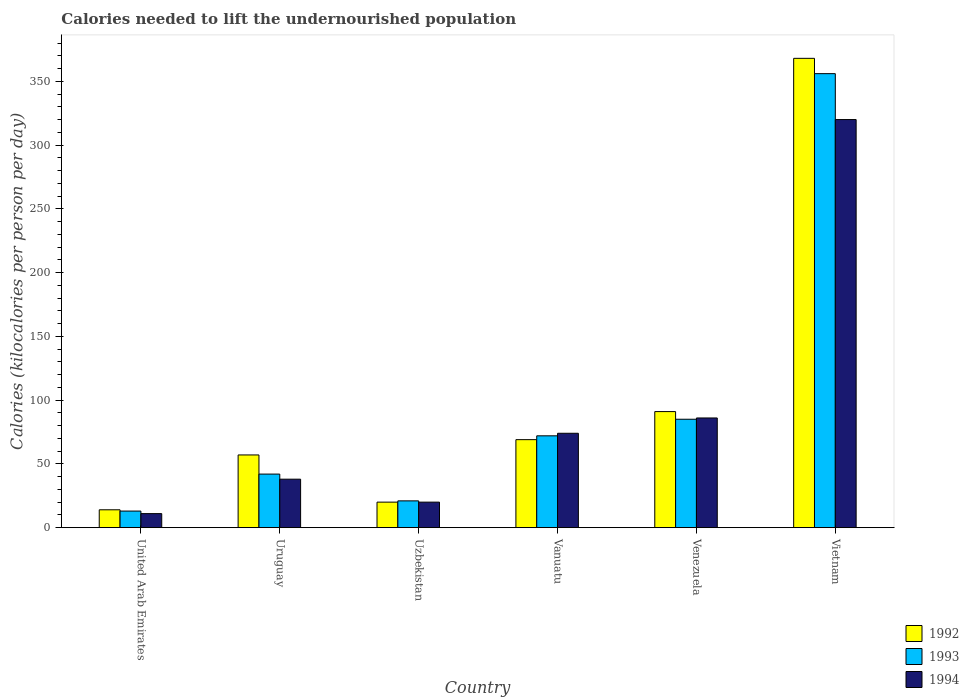How many different coloured bars are there?
Offer a very short reply. 3. What is the label of the 4th group of bars from the left?
Offer a very short reply. Vanuatu. In how many cases, is the number of bars for a given country not equal to the number of legend labels?
Offer a very short reply. 0. Across all countries, what is the maximum total calories needed to lift the undernourished population in 1993?
Offer a very short reply. 356. In which country was the total calories needed to lift the undernourished population in 1994 maximum?
Ensure brevity in your answer.  Vietnam. In which country was the total calories needed to lift the undernourished population in 1992 minimum?
Keep it short and to the point. United Arab Emirates. What is the total total calories needed to lift the undernourished population in 1993 in the graph?
Ensure brevity in your answer.  589. What is the difference between the total calories needed to lift the undernourished population in 1992 in Uruguay and that in Vietnam?
Your answer should be very brief. -311. What is the difference between the total calories needed to lift the undernourished population in 1992 in United Arab Emirates and the total calories needed to lift the undernourished population in 1993 in Vanuatu?
Ensure brevity in your answer.  -58. What is the average total calories needed to lift the undernourished population in 1994 per country?
Make the answer very short. 91.5. What is the difference between the total calories needed to lift the undernourished population of/in 1994 and total calories needed to lift the undernourished population of/in 1993 in Vietnam?
Give a very brief answer. -36. In how many countries, is the total calories needed to lift the undernourished population in 1994 greater than 190 kilocalories?
Your response must be concise. 1. What is the ratio of the total calories needed to lift the undernourished population in 1993 in Uruguay to that in Venezuela?
Offer a terse response. 0.49. Is the total calories needed to lift the undernourished population in 1992 in Uzbekistan less than that in Venezuela?
Ensure brevity in your answer.  Yes. What is the difference between the highest and the second highest total calories needed to lift the undernourished population in 1992?
Ensure brevity in your answer.  277. What is the difference between the highest and the lowest total calories needed to lift the undernourished population in 1993?
Your response must be concise. 343. In how many countries, is the total calories needed to lift the undernourished population in 1994 greater than the average total calories needed to lift the undernourished population in 1994 taken over all countries?
Ensure brevity in your answer.  1. Is the sum of the total calories needed to lift the undernourished population in 1994 in Venezuela and Vietnam greater than the maximum total calories needed to lift the undernourished population in 1993 across all countries?
Your answer should be very brief. Yes. What does the 2nd bar from the left in Vietnam represents?
Offer a terse response. 1993. What does the 3rd bar from the right in Uruguay represents?
Ensure brevity in your answer.  1992. Is it the case that in every country, the sum of the total calories needed to lift the undernourished population in 1993 and total calories needed to lift the undernourished population in 1992 is greater than the total calories needed to lift the undernourished population in 1994?
Your response must be concise. Yes. How many countries are there in the graph?
Keep it short and to the point. 6. What is the difference between two consecutive major ticks on the Y-axis?
Keep it short and to the point. 50. Does the graph contain any zero values?
Offer a very short reply. No. How are the legend labels stacked?
Provide a short and direct response. Vertical. What is the title of the graph?
Your answer should be compact. Calories needed to lift the undernourished population. What is the label or title of the Y-axis?
Your response must be concise. Calories (kilocalories per person per day). What is the Calories (kilocalories per person per day) in 1992 in United Arab Emirates?
Your response must be concise. 14. What is the Calories (kilocalories per person per day) in 1993 in United Arab Emirates?
Offer a terse response. 13. What is the Calories (kilocalories per person per day) in 1994 in United Arab Emirates?
Give a very brief answer. 11. What is the Calories (kilocalories per person per day) in 1993 in Uruguay?
Give a very brief answer. 42. What is the Calories (kilocalories per person per day) of 1994 in Uruguay?
Provide a short and direct response. 38. What is the Calories (kilocalories per person per day) of 1992 in Vanuatu?
Provide a succinct answer. 69. What is the Calories (kilocalories per person per day) in 1994 in Vanuatu?
Offer a terse response. 74. What is the Calories (kilocalories per person per day) in 1992 in Venezuela?
Offer a very short reply. 91. What is the Calories (kilocalories per person per day) in 1992 in Vietnam?
Your answer should be very brief. 368. What is the Calories (kilocalories per person per day) in 1993 in Vietnam?
Your answer should be compact. 356. What is the Calories (kilocalories per person per day) of 1994 in Vietnam?
Provide a succinct answer. 320. Across all countries, what is the maximum Calories (kilocalories per person per day) of 1992?
Ensure brevity in your answer.  368. Across all countries, what is the maximum Calories (kilocalories per person per day) of 1993?
Your answer should be compact. 356. Across all countries, what is the maximum Calories (kilocalories per person per day) in 1994?
Offer a very short reply. 320. What is the total Calories (kilocalories per person per day) in 1992 in the graph?
Provide a succinct answer. 619. What is the total Calories (kilocalories per person per day) in 1993 in the graph?
Provide a short and direct response. 589. What is the total Calories (kilocalories per person per day) of 1994 in the graph?
Make the answer very short. 549. What is the difference between the Calories (kilocalories per person per day) of 1992 in United Arab Emirates and that in Uruguay?
Provide a succinct answer. -43. What is the difference between the Calories (kilocalories per person per day) of 1993 in United Arab Emirates and that in Uruguay?
Provide a short and direct response. -29. What is the difference between the Calories (kilocalories per person per day) of 1994 in United Arab Emirates and that in Uruguay?
Make the answer very short. -27. What is the difference between the Calories (kilocalories per person per day) of 1992 in United Arab Emirates and that in Uzbekistan?
Provide a short and direct response. -6. What is the difference between the Calories (kilocalories per person per day) in 1994 in United Arab Emirates and that in Uzbekistan?
Provide a short and direct response. -9. What is the difference between the Calories (kilocalories per person per day) of 1992 in United Arab Emirates and that in Vanuatu?
Your answer should be compact. -55. What is the difference between the Calories (kilocalories per person per day) of 1993 in United Arab Emirates and that in Vanuatu?
Offer a very short reply. -59. What is the difference between the Calories (kilocalories per person per day) of 1994 in United Arab Emirates and that in Vanuatu?
Give a very brief answer. -63. What is the difference between the Calories (kilocalories per person per day) of 1992 in United Arab Emirates and that in Venezuela?
Provide a succinct answer. -77. What is the difference between the Calories (kilocalories per person per day) of 1993 in United Arab Emirates and that in Venezuela?
Provide a succinct answer. -72. What is the difference between the Calories (kilocalories per person per day) in 1994 in United Arab Emirates and that in Venezuela?
Your answer should be compact. -75. What is the difference between the Calories (kilocalories per person per day) of 1992 in United Arab Emirates and that in Vietnam?
Your answer should be compact. -354. What is the difference between the Calories (kilocalories per person per day) of 1993 in United Arab Emirates and that in Vietnam?
Your answer should be very brief. -343. What is the difference between the Calories (kilocalories per person per day) of 1994 in United Arab Emirates and that in Vietnam?
Provide a short and direct response. -309. What is the difference between the Calories (kilocalories per person per day) of 1994 in Uruguay and that in Uzbekistan?
Provide a succinct answer. 18. What is the difference between the Calories (kilocalories per person per day) of 1992 in Uruguay and that in Vanuatu?
Your answer should be very brief. -12. What is the difference between the Calories (kilocalories per person per day) of 1994 in Uruguay and that in Vanuatu?
Offer a terse response. -36. What is the difference between the Calories (kilocalories per person per day) of 1992 in Uruguay and that in Venezuela?
Provide a short and direct response. -34. What is the difference between the Calories (kilocalories per person per day) in 1993 in Uruguay and that in Venezuela?
Provide a short and direct response. -43. What is the difference between the Calories (kilocalories per person per day) in 1994 in Uruguay and that in Venezuela?
Your answer should be very brief. -48. What is the difference between the Calories (kilocalories per person per day) of 1992 in Uruguay and that in Vietnam?
Make the answer very short. -311. What is the difference between the Calories (kilocalories per person per day) in 1993 in Uruguay and that in Vietnam?
Provide a short and direct response. -314. What is the difference between the Calories (kilocalories per person per day) in 1994 in Uruguay and that in Vietnam?
Your response must be concise. -282. What is the difference between the Calories (kilocalories per person per day) in 1992 in Uzbekistan and that in Vanuatu?
Give a very brief answer. -49. What is the difference between the Calories (kilocalories per person per day) of 1993 in Uzbekistan and that in Vanuatu?
Ensure brevity in your answer.  -51. What is the difference between the Calories (kilocalories per person per day) of 1994 in Uzbekistan and that in Vanuatu?
Offer a terse response. -54. What is the difference between the Calories (kilocalories per person per day) in 1992 in Uzbekistan and that in Venezuela?
Keep it short and to the point. -71. What is the difference between the Calories (kilocalories per person per day) of 1993 in Uzbekistan and that in Venezuela?
Provide a succinct answer. -64. What is the difference between the Calories (kilocalories per person per day) of 1994 in Uzbekistan and that in Venezuela?
Ensure brevity in your answer.  -66. What is the difference between the Calories (kilocalories per person per day) in 1992 in Uzbekistan and that in Vietnam?
Your answer should be very brief. -348. What is the difference between the Calories (kilocalories per person per day) in 1993 in Uzbekistan and that in Vietnam?
Provide a short and direct response. -335. What is the difference between the Calories (kilocalories per person per day) of 1994 in Uzbekistan and that in Vietnam?
Your answer should be compact. -300. What is the difference between the Calories (kilocalories per person per day) in 1993 in Vanuatu and that in Venezuela?
Provide a succinct answer. -13. What is the difference between the Calories (kilocalories per person per day) in 1992 in Vanuatu and that in Vietnam?
Provide a short and direct response. -299. What is the difference between the Calories (kilocalories per person per day) in 1993 in Vanuatu and that in Vietnam?
Your response must be concise. -284. What is the difference between the Calories (kilocalories per person per day) of 1994 in Vanuatu and that in Vietnam?
Offer a terse response. -246. What is the difference between the Calories (kilocalories per person per day) of 1992 in Venezuela and that in Vietnam?
Ensure brevity in your answer.  -277. What is the difference between the Calories (kilocalories per person per day) of 1993 in Venezuela and that in Vietnam?
Your answer should be very brief. -271. What is the difference between the Calories (kilocalories per person per day) in 1994 in Venezuela and that in Vietnam?
Keep it short and to the point. -234. What is the difference between the Calories (kilocalories per person per day) of 1993 in United Arab Emirates and the Calories (kilocalories per person per day) of 1994 in Uruguay?
Keep it short and to the point. -25. What is the difference between the Calories (kilocalories per person per day) of 1992 in United Arab Emirates and the Calories (kilocalories per person per day) of 1993 in Uzbekistan?
Your answer should be compact. -7. What is the difference between the Calories (kilocalories per person per day) of 1992 in United Arab Emirates and the Calories (kilocalories per person per day) of 1993 in Vanuatu?
Your response must be concise. -58. What is the difference between the Calories (kilocalories per person per day) in 1992 in United Arab Emirates and the Calories (kilocalories per person per day) in 1994 in Vanuatu?
Your answer should be compact. -60. What is the difference between the Calories (kilocalories per person per day) of 1993 in United Arab Emirates and the Calories (kilocalories per person per day) of 1994 in Vanuatu?
Provide a succinct answer. -61. What is the difference between the Calories (kilocalories per person per day) of 1992 in United Arab Emirates and the Calories (kilocalories per person per day) of 1993 in Venezuela?
Make the answer very short. -71. What is the difference between the Calories (kilocalories per person per day) of 1992 in United Arab Emirates and the Calories (kilocalories per person per day) of 1994 in Venezuela?
Give a very brief answer. -72. What is the difference between the Calories (kilocalories per person per day) in 1993 in United Arab Emirates and the Calories (kilocalories per person per day) in 1994 in Venezuela?
Provide a short and direct response. -73. What is the difference between the Calories (kilocalories per person per day) of 1992 in United Arab Emirates and the Calories (kilocalories per person per day) of 1993 in Vietnam?
Your response must be concise. -342. What is the difference between the Calories (kilocalories per person per day) in 1992 in United Arab Emirates and the Calories (kilocalories per person per day) in 1994 in Vietnam?
Your answer should be very brief. -306. What is the difference between the Calories (kilocalories per person per day) in 1993 in United Arab Emirates and the Calories (kilocalories per person per day) in 1994 in Vietnam?
Give a very brief answer. -307. What is the difference between the Calories (kilocalories per person per day) of 1992 in Uruguay and the Calories (kilocalories per person per day) of 1993 in Uzbekistan?
Your answer should be compact. 36. What is the difference between the Calories (kilocalories per person per day) in 1992 in Uruguay and the Calories (kilocalories per person per day) in 1994 in Uzbekistan?
Offer a terse response. 37. What is the difference between the Calories (kilocalories per person per day) of 1993 in Uruguay and the Calories (kilocalories per person per day) of 1994 in Uzbekistan?
Offer a very short reply. 22. What is the difference between the Calories (kilocalories per person per day) of 1992 in Uruguay and the Calories (kilocalories per person per day) of 1994 in Vanuatu?
Provide a succinct answer. -17. What is the difference between the Calories (kilocalories per person per day) of 1993 in Uruguay and the Calories (kilocalories per person per day) of 1994 in Vanuatu?
Offer a terse response. -32. What is the difference between the Calories (kilocalories per person per day) of 1992 in Uruguay and the Calories (kilocalories per person per day) of 1993 in Venezuela?
Your answer should be very brief. -28. What is the difference between the Calories (kilocalories per person per day) in 1992 in Uruguay and the Calories (kilocalories per person per day) in 1994 in Venezuela?
Give a very brief answer. -29. What is the difference between the Calories (kilocalories per person per day) in 1993 in Uruguay and the Calories (kilocalories per person per day) in 1994 in Venezuela?
Offer a very short reply. -44. What is the difference between the Calories (kilocalories per person per day) of 1992 in Uruguay and the Calories (kilocalories per person per day) of 1993 in Vietnam?
Make the answer very short. -299. What is the difference between the Calories (kilocalories per person per day) in 1992 in Uruguay and the Calories (kilocalories per person per day) in 1994 in Vietnam?
Give a very brief answer. -263. What is the difference between the Calories (kilocalories per person per day) in 1993 in Uruguay and the Calories (kilocalories per person per day) in 1994 in Vietnam?
Offer a very short reply. -278. What is the difference between the Calories (kilocalories per person per day) of 1992 in Uzbekistan and the Calories (kilocalories per person per day) of 1993 in Vanuatu?
Your response must be concise. -52. What is the difference between the Calories (kilocalories per person per day) in 1992 in Uzbekistan and the Calories (kilocalories per person per day) in 1994 in Vanuatu?
Keep it short and to the point. -54. What is the difference between the Calories (kilocalories per person per day) of 1993 in Uzbekistan and the Calories (kilocalories per person per day) of 1994 in Vanuatu?
Your answer should be compact. -53. What is the difference between the Calories (kilocalories per person per day) in 1992 in Uzbekistan and the Calories (kilocalories per person per day) in 1993 in Venezuela?
Keep it short and to the point. -65. What is the difference between the Calories (kilocalories per person per day) of 1992 in Uzbekistan and the Calories (kilocalories per person per day) of 1994 in Venezuela?
Your response must be concise. -66. What is the difference between the Calories (kilocalories per person per day) of 1993 in Uzbekistan and the Calories (kilocalories per person per day) of 1994 in Venezuela?
Provide a succinct answer. -65. What is the difference between the Calories (kilocalories per person per day) in 1992 in Uzbekistan and the Calories (kilocalories per person per day) in 1993 in Vietnam?
Keep it short and to the point. -336. What is the difference between the Calories (kilocalories per person per day) of 1992 in Uzbekistan and the Calories (kilocalories per person per day) of 1994 in Vietnam?
Provide a short and direct response. -300. What is the difference between the Calories (kilocalories per person per day) in 1993 in Uzbekistan and the Calories (kilocalories per person per day) in 1994 in Vietnam?
Provide a short and direct response. -299. What is the difference between the Calories (kilocalories per person per day) of 1993 in Vanuatu and the Calories (kilocalories per person per day) of 1994 in Venezuela?
Your answer should be very brief. -14. What is the difference between the Calories (kilocalories per person per day) of 1992 in Vanuatu and the Calories (kilocalories per person per day) of 1993 in Vietnam?
Your answer should be very brief. -287. What is the difference between the Calories (kilocalories per person per day) in 1992 in Vanuatu and the Calories (kilocalories per person per day) in 1994 in Vietnam?
Make the answer very short. -251. What is the difference between the Calories (kilocalories per person per day) of 1993 in Vanuatu and the Calories (kilocalories per person per day) of 1994 in Vietnam?
Ensure brevity in your answer.  -248. What is the difference between the Calories (kilocalories per person per day) in 1992 in Venezuela and the Calories (kilocalories per person per day) in 1993 in Vietnam?
Give a very brief answer. -265. What is the difference between the Calories (kilocalories per person per day) of 1992 in Venezuela and the Calories (kilocalories per person per day) of 1994 in Vietnam?
Keep it short and to the point. -229. What is the difference between the Calories (kilocalories per person per day) in 1993 in Venezuela and the Calories (kilocalories per person per day) in 1994 in Vietnam?
Your answer should be compact. -235. What is the average Calories (kilocalories per person per day) in 1992 per country?
Keep it short and to the point. 103.17. What is the average Calories (kilocalories per person per day) of 1993 per country?
Make the answer very short. 98.17. What is the average Calories (kilocalories per person per day) of 1994 per country?
Provide a short and direct response. 91.5. What is the difference between the Calories (kilocalories per person per day) of 1992 and Calories (kilocalories per person per day) of 1994 in United Arab Emirates?
Offer a very short reply. 3. What is the difference between the Calories (kilocalories per person per day) in 1993 and Calories (kilocalories per person per day) in 1994 in United Arab Emirates?
Offer a terse response. 2. What is the difference between the Calories (kilocalories per person per day) in 1992 and Calories (kilocalories per person per day) in 1993 in Uruguay?
Your answer should be compact. 15. What is the difference between the Calories (kilocalories per person per day) in 1993 and Calories (kilocalories per person per day) in 1994 in Uruguay?
Give a very brief answer. 4. What is the difference between the Calories (kilocalories per person per day) in 1992 and Calories (kilocalories per person per day) in 1993 in Uzbekistan?
Your response must be concise. -1. What is the difference between the Calories (kilocalories per person per day) in 1992 and Calories (kilocalories per person per day) in 1994 in Uzbekistan?
Ensure brevity in your answer.  0. What is the difference between the Calories (kilocalories per person per day) of 1992 and Calories (kilocalories per person per day) of 1993 in Vanuatu?
Keep it short and to the point. -3. What is the difference between the Calories (kilocalories per person per day) in 1992 and Calories (kilocalories per person per day) in 1994 in Vanuatu?
Offer a very short reply. -5. What is the difference between the Calories (kilocalories per person per day) in 1993 and Calories (kilocalories per person per day) in 1994 in Vanuatu?
Offer a very short reply. -2. What is the difference between the Calories (kilocalories per person per day) of 1992 and Calories (kilocalories per person per day) of 1993 in Venezuela?
Offer a terse response. 6. What is the difference between the Calories (kilocalories per person per day) of 1992 and Calories (kilocalories per person per day) of 1994 in Vietnam?
Make the answer very short. 48. What is the ratio of the Calories (kilocalories per person per day) in 1992 in United Arab Emirates to that in Uruguay?
Offer a terse response. 0.25. What is the ratio of the Calories (kilocalories per person per day) in 1993 in United Arab Emirates to that in Uruguay?
Keep it short and to the point. 0.31. What is the ratio of the Calories (kilocalories per person per day) of 1994 in United Arab Emirates to that in Uruguay?
Give a very brief answer. 0.29. What is the ratio of the Calories (kilocalories per person per day) of 1992 in United Arab Emirates to that in Uzbekistan?
Make the answer very short. 0.7. What is the ratio of the Calories (kilocalories per person per day) in 1993 in United Arab Emirates to that in Uzbekistan?
Offer a terse response. 0.62. What is the ratio of the Calories (kilocalories per person per day) of 1994 in United Arab Emirates to that in Uzbekistan?
Offer a very short reply. 0.55. What is the ratio of the Calories (kilocalories per person per day) of 1992 in United Arab Emirates to that in Vanuatu?
Your answer should be compact. 0.2. What is the ratio of the Calories (kilocalories per person per day) of 1993 in United Arab Emirates to that in Vanuatu?
Make the answer very short. 0.18. What is the ratio of the Calories (kilocalories per person per day) in 1994 in United Arab Emirates to that in Vanuatu?
Provide a succinct answer. 0.15. What is the ratio of the Calories (kilocalories per person per day) in 1992 in United Arab Emirates to that in Venezuela?
Make the answer very short. 0.15. What is the ratio of the Calories (kilocalories per person per day) of 1993 in United Arab Emirates to that in Venezuela?
Your answer should be very brief. 0.15. What is the ratio of the Calories (kilocalories per person per day) of 1994 in United Arab Emirates to that in Venezuela?
Offer a very short reply. 0.13. What is the ratio of the Calories (kilocalories per person per day) of 1992 in United Arab Emirates to that in Vietnam?
Provide a short and direct response. 0.04. What is the ratio of the Calories (kilocalories per person per day) of 1993 in United Arab Emirates to that in Vietnam?
Make the answer very short. 0.04. What is the ratio of the Calories (kilocalories per person per day) in 1994 in United Arab Emirates to that in Vietnam?
Offer a terse response. 0.03. What is the ratio of the Calories (kilocalories per person per day) of 1992 in Uruguay to that in Uzbekistan?
Provide a succinct answer. 2.85. What is the ratio of the Calories (kilocalories per person per day) in 1993 in Uruguay to that in Uzbekistan?
Ensure brevity in your answer.  2. What is the ratio of the Calories (kilocalories per person per day) of 1992 in Uruguay to that in Vanuatu?
Provide a succinct answer. 0.83. What is the ratio of the Calories (kilocalories per person per day) in 1993 in Uruguay to that in Vanuatu?
Your answer should be compact. 0.58. What is the ratio of the Calories (kilocalories per person per day) of 1994 in Uruguay to that in Vanuatu?
Make the answer very short. 0.51. What is the ratio of the Calories (kilocalories per person per day) of 1992 in Uruguay to that in Venezuela?
Provide a succinct answer. 0.63. What is the ratio of the Calories (kilocalories per person per day) in 1993 in Uruguay to that in Venezuela?
Your answer should be very brief. 0.49. What is the ratio of the Calories (kilocalories per person per day) in 1994 in Uruguay to that in Venezuela?
Provide a succinct answer. 0.44. What is the ratio of the Calories (kilocalories per person per day) in 1992 in Uruguay to that in Vietnam?
Make the answer very short. 0.15. What is the ratio of the Calories (kilocalories per person per day) in 1993 in Uruguay to that in Vietnam?
Offer a terse response. 0.12. What is the ratio of the Calories (kilocalories per person per day) of 1994 in Uruguay to that in Vietnam?
Provide a succinct answer. 0.12. What is the ratio of the Calories (kilocalories per person per day) in 1992 in Uzbekistan to that in Vanuatu?
Offer a terse response. 0.29. What is the ratio of the Calories (kilocalories per person per day) in 1993 in Uzbekistan to that in Vanuatu?
Offer a very short reply. 0.29. What is the ratio of the Calories (kilocalories per person per day) of 1994 in Uzbekistan to that in Vanuatu?
Ensure brevity in your answer.  0.27. What is the ratio of the Calories (kilocalories per person per day) in 1992 in Uzbekistan to that in Venezuela?
Keep it short and to the point. 0.22. What is the ratio of the Calories (kilocalories per person per day) in 1993 in Uzbekistan to that in Venezuela?
Your answer should be very brief. 0.25. What is the ratio of the Calories (kilocalories per person per day) of 1994 in Uzbekistan to that in Venezuela?
Your answer should be compact. 0.23. What is the ratio of the Calories (kilocalories per person per day) in 1992 in Uzbekistan to that in Vietnam?
Provide a short and direct response. 0.05. What is the ratio of the Calories (kilocalories per person per day) in 1993 in Uzbekistan to that in Vietnam?
Keep it short and to the point. 0.06. What is the ratio of the Calories (kilocalories per person per day) in 1994 in Uzbekistan to that in Vietnam?
Offer a very short reply. 0.06. What is the ratio of the Calories (kilocalories per person per day) of 1992 in Vanuatu to that in Venezuela?
Your answer should be compact. 0.76. What is the ratio of the Calories (kilocalories per person per day) of 1993 in Vanuatu to that in Venezuela?
Provide a short and direct response. 0.85. What is the ratio of the Calories (kilocalories per person per day) in 1994 in Vanuatu to that in Venezuela?
Give a very brief answer. 0.86. What is the ratio of the Calories (kilocalories per person per day) in 1992 in Vanuatu to that in Vietnam?
Offer a terse response. 0.19. What is the ratio of the Calories (kilocalories per person per day) in 1993 in Vanuatu to that in Vietnam?
Make the answer very short. 0.2. What is the ratio of the Calories (kilocalories per person per day) of 1994 in Vanuatu to that in Vietnam?
Your response must be concise. 0.23. What is the ratio of the Calories (kilocalories per person per day) of 1992 in Venezuela to that in Vietnam?
Make the answer very short. 0.25. What is the ratio of the Calories (kilocalories per person per day) of 1993 in Venezuela to that in Vietnam?
Ensure brevity in your answer.  0.24. What is the ratio of the Calories (kilocalories per person per day) of 1994 in Venezuela to that in Vietnam?
Keep it short and to the point. 0.27. What is the difference between the highest and the second highest Calories (kilocalories per person per day) of 1992?
Give a very brief answer. 277. What is the difference between the highest and the second highest Calories (kilocalories per person per day) in 1993?
Your answer should be very brief. 271. What is the difference between the highest and the second highest Calories (kilocalories per person per day) in 1994?
Give a very brief answer. 234. What is the difference between the highest and the lowest Calories (kilocalories per person per day) of 1992?
Keep it short and to the point. 354. What is the difference between the highest and the lowest Calories (kilocalories per person per day) in 1993?
Make the answer very short. 343. What is the difference between the highest and the lowest Calories (kilocalories per person per day) of 1994?
Provide a short and direct response. 309. 